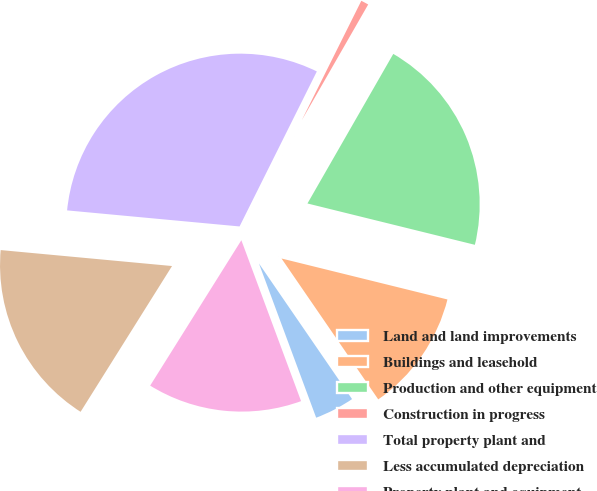<chart> <loc_0><loc_0><loc_500><loc_500><pie_chart><fcel>Land and land improvements<fcel>Buildings and leasehold<fcel>Production and other equipment<fcel>Construction in progress<fcel>Total property plant and<fcel>Less accumulated depreciation<fcel>Property plant and equipment<nl><fcel>3.92%<fcel>11.57%<fcel>20.56%<fcel>0.93%<fcel>30.88%<fcel>17.56%<fcel>14.57%<nl></chart> 